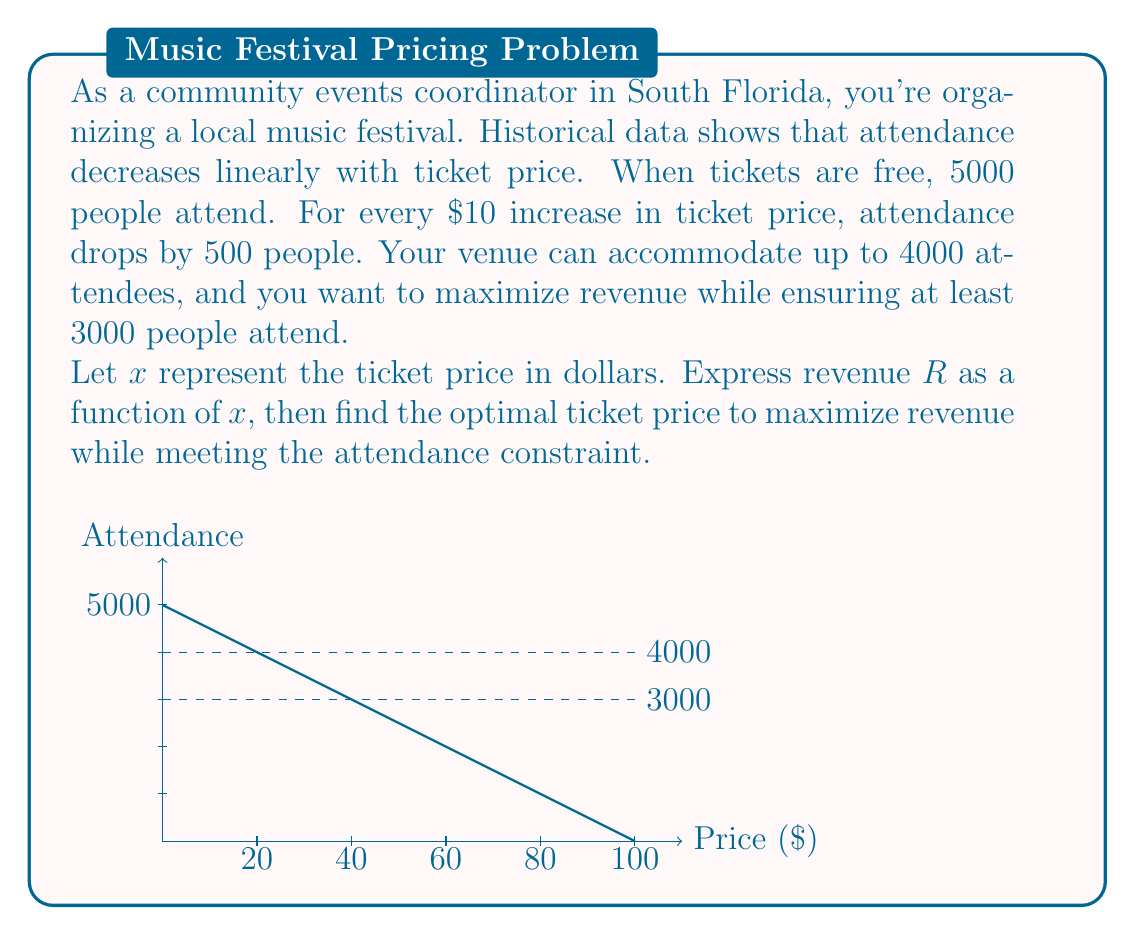What is the answer to this math problem? Let's approach this step-by-step:

1) First, we need to express attendance as a function of price:
   Attendance = $5000 - 50x$

2) Revenue is price multiplied by attendance:
   $R(x) = x(5000 - 50x) = 5000x - 50x^2$

3) The constraint of at least 3000 attendees means:
   $5000 - 50x \geq 3000$
   $-50x \geq -2000$
   $x \leq 40$

4) To find the maximum revenue, we differentiate $R(x)$ and set it to zero:
   $\frac{dR}{dx} = 5000 - 100x$
   $5000 - 100x = 0$
   $x = 50$

5) However, $x = 50$ violates our attendance constraint. Therefore, the maximum revenue within our constraint will occur at $x = 40$.

6) Let's verify the revenue at $x = 40$:
   $R(40) = 40(5000 - 50(40)) = 40(3000) = 120,000$

7) The attendance at this price is:
   $5000 - 50(40) = 3000$, which meets our minimum attendance requirement.
Answer: $40 per ticket 